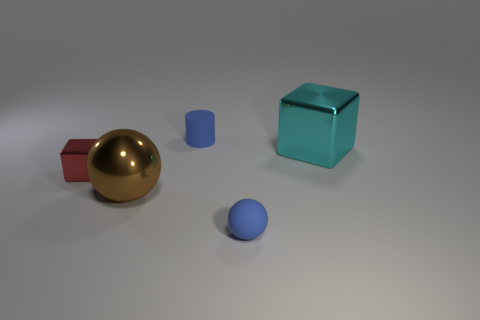What size is the metal thing that is both right of the red metal thing and to the left of the big cyan object?
Ensure brevity in your answer.  Large. There is a object right of the small thing in front of the cube in front of the big cube; what size is it?
Your response must be concise. Large. The rubber cylinder is what size?
Provide a short and direct response. Small. There is a ball left of the small thing in front of the red metal cube; is there a metal block that is to the right of it?
Provide a short and direct response. Yes. What number of big objects are either red metal cubes or green rubber balls?
Your response must be concise. 0. Is there any other thing that is the same color as the tiny cylinder?
Your response must be concise. Yes. There is a rubber sphere in front of the cyan metal block; is its size the same as the large cyan cube?
Offer a very short reply. No. What color is the tiny matte thing that is to the right of the tiny matte thing left of the small blue thing in front of the big cyan shiny block?
Keep it short and to the point. Blue. What color is the small block?
Give a very brief answer. Red. Do the tiny ball and the tiny matte cylinder have the same color?
Your answer should be very brief. Yes. 